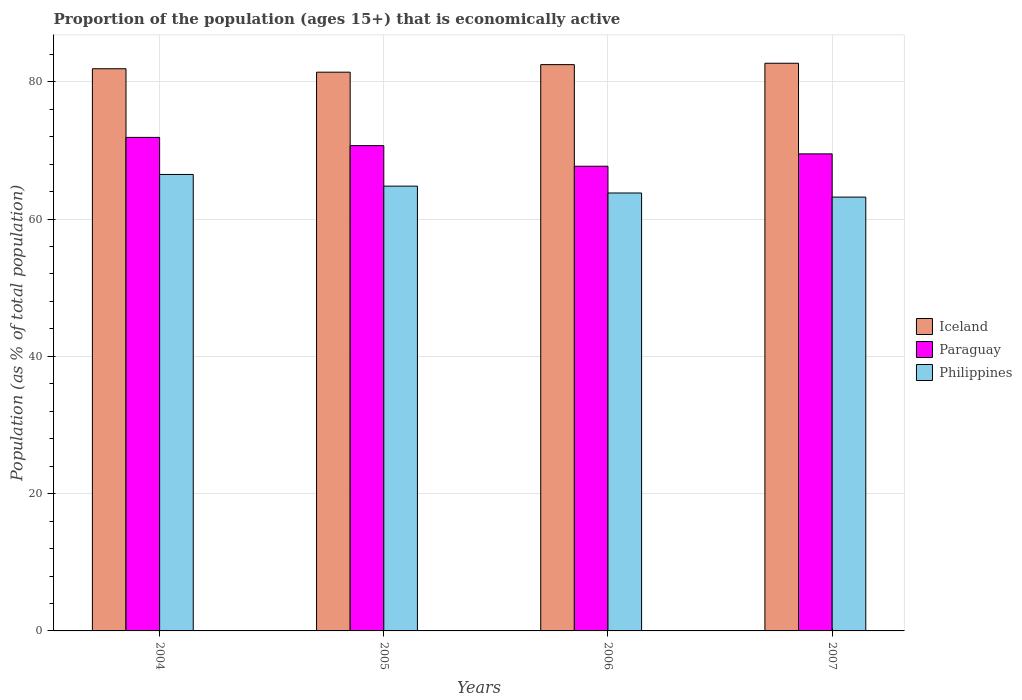How many groups of bars are there?
Offer a very short reply. 4. Are the number of bars per tick equal to the number of legend labels?
Ensure brevity in your answer.  Yes. How many bars are there on the 4th tick from the left?
Make the answer very short. 3. In how many cases, is the number of bars for a given year not equal to the number of legend labels?
Keep it short and to the point. 0. What is the proportion of the population that is economically active in Paraguay in 2004?
Ensure brevity in your answer.  71.9. Across all years, what is the maximum proportion of the population that is economically active in Paraguay?
Offer a very short reply. 71.9. Across all years, what is the minimum proportion of the population that is economically active in Iceland?
Your answer should be very brief. 81.4. In which year was the proportion of the population that is economically active in Iceland maximum?
Provide a succinct answer. 2007. In which year was the proportion of the population that is economically active in Iceland minimum?
Offer a very short reply. 2005. What is the total proportion of the population that is economically active in Iceland in the graph?
Ensure brevity in your answer.  328.5. What is the difference between the proportion of the population that is economically active in Iceland in 2006 and that in 2007?
Offer a terse response. -0.2. What is the difference between the proportion of the population that is economically active in Paraguay in 2007 and the proportion of the population that is economically active in Philippines in 2005?
Offer a very short reply. 4.7. What is the average proportion of the population that is economically active in Paraguay per year?
Your answer should be very brief. 69.95. In the year 2005, what is the difference between the proportion of the population that is economically active in Paraguay and proportion of the population that is economically active in Iceland?
Offer a very short reply. -10.7. In how many years, is the proportion of the population that is economically active in Paraguay greater than 60 %?
Your response must be concise. 4. What is the ratio of the proportion of the population that is economically active in Iceland in 2006 to that in 2007?
Ensure brevity in your answer.  1. Is the difference between the proportion of the population that is economically active in Paraguay in 2004 and 2007 greater than the difference between the proportion of the population that is economically active in Iceland in 2004 and 2007?
Provide a succinct answer. Yes. What is the difference between the highest and the second highest proportion of the population that is economically active in Philippines?
Offer a very short reply. 1.7. What is the difference between the highest and the lowest proportion of the population that is economically active in Iceland?
Provide a succinct answer. 1.3. In how many years, is the proportion of the population that is economically active in Paraguay greater than the average proportion of the population that is economically active in Paraguay taken over all years?
Provide a succinct answer. 2. Is the sum of the proportion of the population that is economically active in Iceland in 2006 and 2007 greater than the maximum proportion of the population that is economically active in Philippines across all years?
Offer a very short reply. Yes. What does the 3rd bar from the right in 2007 represents?
Make the answer very short. Iceland. How many bars are there?
Provide a short and direct response. 12. Does the graph contain grids?
Offer a terse response. Yes. How are the legend labels stacked?
Keep it short and to the point. Vertical. What is the title of the graph?
Offer a very short reply. Proportion of the population (ages 15+) that is economically active. Does "Swaziland" appear as one of the legend labels in the graph?
Make the answer very short. No. What is the label or title of the Y-axis?
Give a very brief answer. Population (as % of total population). What is the Population (as % of total population) in Iceland in 2004?
Make the answer very short. 81.9. What is the Population (as % of total population) in Paraguay in 2004?
Ensure brevity in your answer.  71.9. What is the Population (as % of total population) of Philippines in 2004?
Make the answer very short. 66.5. What is the Population (as % of total population) of Iceland in 2005?
Provide a succinct answer. 81.4. What is the Population (as % of total population) of Paraguay in 2005?
Keep it short and to the point. 70.7. What is the Population (as % of total population) of Philippines in 2005?
Give a very brief answer. 64.8. What is the Population (as % of total population) in Iceland in 2006?
Offer a terse response. 82.5. What is the Population (as % of total population) in Paraguay in 2006?
Provide a succinct answer. 67.7. What is the Population (as % of total population) in Philippines in 2006?
Provide a succinct answer. 63.8. What is the Population (as % of total population) of Iceland in 2007?
Provide a short and direct response. 82.7. What is the Population (as % of total population) of Paraguay in 2007?
Your answer should be very brief. 69.5. What is the Population (as % of total population) in Philippines in 2007?
Make the answer very short. 63.2. Across all years, what is the maximum Population (as % of total population) in Iceland?
Make the answer very short. 82.7. Across all years, what is the maximum Population (as % of total population) of Paraguay?
Your answer should be compact. 71.9. Across all years, what is the maximum Population (as % of total population) of Philippines?
Your answer should be very brief. 66.5. Across all years, what is the minimum Population (as % of total population) of Iceland?
Offer a terse response. 81.4. Across all years, what is the minimum Population (as % of total population) of Paraguay?
Your answer should be compact. 67.7. Across all years, what is the minimum Population (as % of total population) in Philippines?
Your response must be concise. 63.2. What is the total Population (as % of total population) of Iceland in the graph?
Offer a terse response. 328.5. What is the total Population (as % of total population) in Paraguay in the graph?
Ensure brevity in your answer.  279.8. What is the total Population (as % of total population) of Philippines in the graph?
Offer a terse response. 258.3. What is the difference between the Population (as % of total population) of Iceland in 2004 and that in 2005?
Make the answer very short. 0.5. What is the difference between the Population (as % of total population) of Paraguay in 2004 and that in 2006?
Offer a very short reply. 4.2. What is the difference between the Population (as % of total population) of Philippines in 2004 and that in 2006?
Provide a short and direct response. 2.7. What is the difference between the Population (as % of total population) in Iceland in 2004 and that in 2007?
Your answer should be very brief. -0.8. What is the difference between the Population (as % of total population) in Paraguay in 2005 and that in 2006?
Your response must be concise. 3. What is the difference between the Population (as % of total population) in Philippines in 2005 and that in 2006?
Your answer should be very brief. 1. What is the difference between the Population (as % of total population) of Iceland in 2005 and that in 2007?
Your response must be concise. -1.3. What is the difference between the Population (as % of total population) in Paraguay in 2005 and that in 2007?
Give a very brief answer. 1.2. What is the difference between the Population (as % of total population) in Philippines in 2005 and that in 2007?
Your answer should be very brief. 1.6. What is the difference between the Population (as % of total population) of Philippines in 2006 and that in 2007?
Offer a terse response. 0.6. What is the difference between the Population (as % of total population) of Iceland in 2004 and the Population (as % of total population) of Paraguay in 2005?
Provide a succinct answer. 11.2. What is the difference between the Population (as % of total population) of Paraguay in 2004 and the Population (as % of total population) of Philippines in 2005?
Your answer should be very brief. 7.1. What is the difference between the Population (as % of total population) in Paraguay in 2004 and the Population (as % of total population) in Philippines in 2006?
Provide a succinct answer. 8.1. What is the difference between the Population (as % of total population) in Iceland in 2004 and the Population (as % of total population) in Paraguay in 2007?
Your answer should be very brief. 12.4. What is the difference between the Population (as % of total population) in Iceland in 2005 and the Population (as % of total population) in Paraguay in 2006?
Ensure brevity in your answer.  13.7. What is the difference between the Population (as % of total population) of Iceland in 2005 and the Population (as % of total population) of Philippines in 2006?
Keep it short and to the point. 17.6. What is the difference between the Population (as % of total population) in Iceland in 2005 and the Population (as % of total population) in Paraguay in 2007?
Keep it short and to the point. 11.9. What is the difference between the Population (as % of total population) of Iceland in 2005 and the Population (as % of total population) of Philippines in 2007?
Ensure brevity in your answer.  18.2. What is the difference between the Population (as % of total population) of Iceland in 2006 and the Population (as % of total population) of Philippines in 2007?
Your answer should be very brief. 19.3. What is the average Population (as % of total population) in Iceland per year?
Offer a terse response. 82.12. What is the average Population (as % of total population) in Paraguay per year?
Keep it short and to the point. 69.95. What is the average Population (as % of total population) of Philippines per year?
Keep it short and to the point. 64.58. In the year 2004, what is the difference between the Population (as % of total population) of Paraguay and Population (as % of total population) of Philippines?
Make the answer very short. 5.4. In the year 2006, what is the difference between the Population (as % of total population) of Iceland and Population (as % of total population) of Paraguay?
Your response must be concise. 14.8. In the year 2006, what is the difference between the Population (as % of total population) of Iceland and Population (as % of total population) of Philippines?
Offer a very short reply. 18.7. In the year 2006, what is the difference between the Population (as % of total population) of Paraguay and Population (as % of total population) of Philippines?
Your answer should be very brief. 3.9. In the year 2007, what is the difference between the Population (as % of total population) in Paraguay and Population (as % of total population) in Philippines?
Make the answer very short. 6.3. What is the ratio of the Population (as % of total population) in Iceland in 2004 to that in 2005?
Provide a succinct answer. 1.01. What is the ratio of the Population (as % of total population) in Paraguay in 2004 to that in 2005?
Provide a succinct answer. 1.02. What is the ratio of the Population (as % of total population) of Philippines in 2004 to that in 2005?
Make the answer very short. 1.03. What is the ratio of the Population (as % of total population) in Paraguay in 2004 to that in 2006?
Your response must be concise. 1.06. What is the ratio of the Population (as % of total population) in Philippines in 2004 to that in 2006?
Keep it short and to the point. 1.04. What is the ratio of the Population (as % of total population) in Iceland in 2004 to that in 2007?
Offer a terse response. 0.99. What is the ratio of the Population (as % of total population) in Paraguay in 2004 to that in 2007?
Give a very brief answer. 1.03. What is the ratio of the Population (as % of total population) in Philippines in 2004 to that in 2007?
Make the answer very short. 1.05. What is the ratio of the Population (as % of total population) of Iceland in 2005 to that in 2006?
Provide a succinct answer. 0.99. What is the ratio of the Population (as % of total population) in Paraguay in 2005 to that in 2006?
Offer a terse response. 1.04. What is the ratio of the Population (as % of total population) in Philippines in 2005 to that in 2006?
Give a very brief answer. 1.02. What is the ratio of the Population (as % of total population) of Iceland in 2005 to that in 2007?
Make the answer very short. 0.98. What is the ratio of the Population (as % of total population) in Paraguay in 2005 to that in 2007?
Your answer should be compact. 1.02. What is the ratio of the Population (as % of total population) of Philippines in 2005 to that in 2007?
Ensure brevity in your answer.  1.03. What is the ratio of the Population (as % of total population) in Iceland in 2006 to that in 2007?
Your answer should be compact. 1. What is the ratio of the Population (as % of total population) in Paraguay in 2006 to that in 2007?
Provide a succinct answer. 0.97. What is the ratio of the Population (as % of total population) of Philippines in 2006 to that in 2007?
Provide a succinct answer. 1.01. What is the difference between the highest and the second highest Population (as % of total population) in Paraguay?
Your response must be concise. 1.2. What is the difference between the highest and the lowest Population (as % of total population) of Iceland?
Offer a terse response. 1.3. What is the difference between the highest and the lowest Population (as % of total population) in Paraguay?
Give a very brief answer. 4.2. 